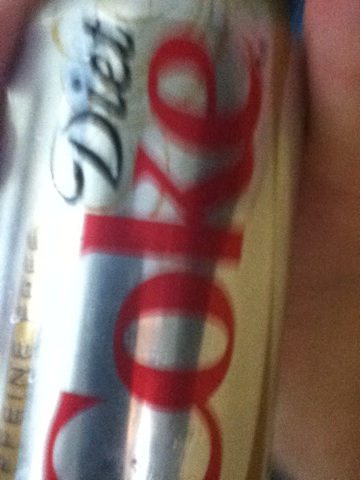Is there anything unique about this can's design compared to the standard Diet Coke can? This particular can features the classic design for Diet Coke with its sleek silver background and distinct red lettering. Each Diet Coke can design may vary slightly depending on special editions or regional designs, but this one seems to adhere to the widely recognized style. 